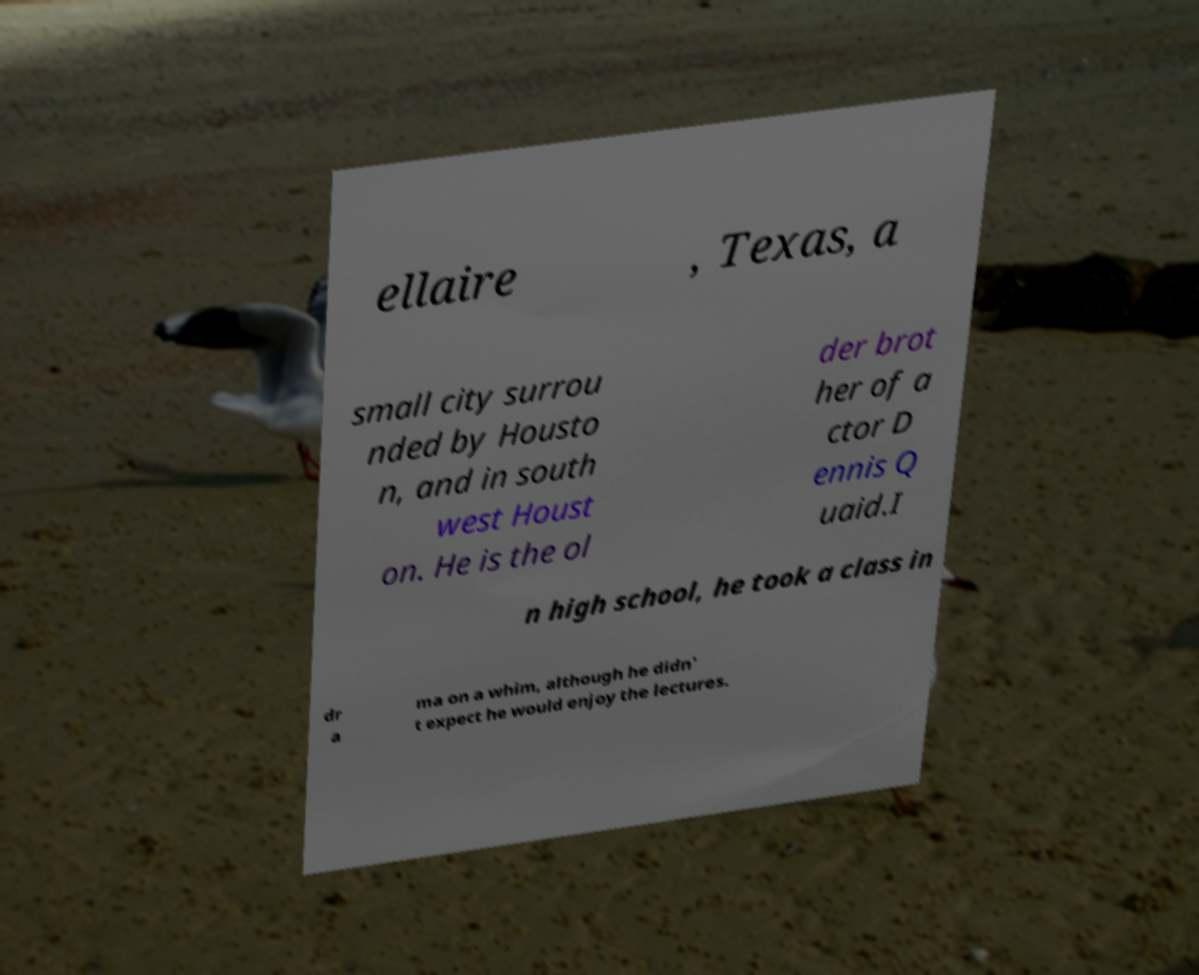Please read and relay the text visible in this image. What does it say? ellaire , Texas, a small city surrou nded by Housto n, and in south west Houst on. He is the ol der brot her of a ctor D ennis Q uaid.I n high school, he took a class in dr a ma on a whim, although he didn' t expect he would enjoy the lectures. 